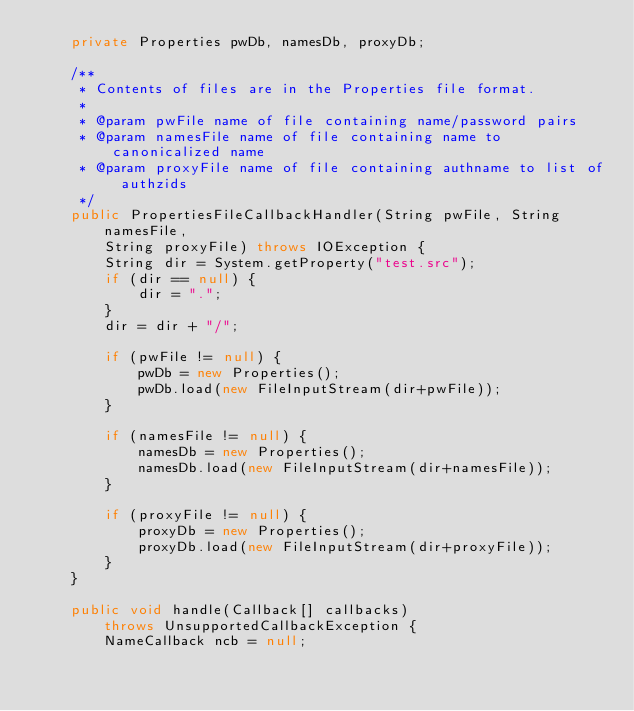Convert code to text. <code><loc_0><loc_0><loc_500><loc_500><_Java_>    private Properties pwDb, namesDb, proxyDb;

    /**
     * Contents of files are in the Properties file format.
     *
     * @param pwFile name of file containing name/password pairs
     * @param namesFile name of file containing name to canonicalized name
     * @param proxyFile name of file containing authname to list of authzids
     */
    public PropertiesFileCallbackHandler(String pwFile, String namesFile,
        String proxyFile) throws IOException {
        String dir = System.getProperty("test.src");
        if (dir == null) {
            dir = ".";
        }
        dir = dir + "/";

        if (pwFile != null) {
            pwDb = new Properties();
            pwDb.load(new FileInputStream(dir+pwFile));
        }

        if (namesFile != null) {
            namesDb = new Properties();
            namesDb.load(new FileInputStream(dir+namesFile));
        }

        if (proxyFile != null) {
            proxyDb = new Properties();
            proxyDb.load(new FileInputStream(dir+proxyFile));
        }
    }

    public void handle(Callback[] callbacks)
        throws UnsupportedCallbackException {
        NameCallback ncb = null;</code> 